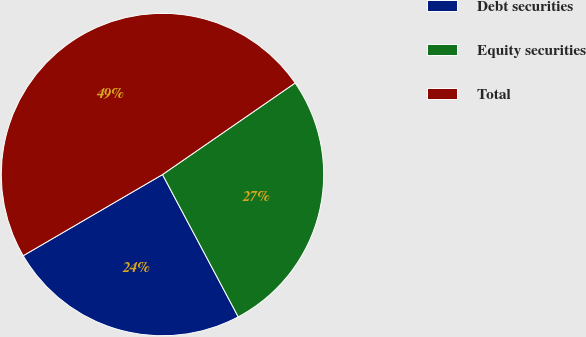Convert chart. <chart><loc_0><loc_0><loc_500><loc_500><pie_chart><fcel>Debt securities<fcel>Equity securities<fcel>Total<nl><fcel>24.39%<fcel>26.83%<fcel>48.78%<nl></chart> 